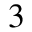Convert formula to latex. <formula><loc_0><loc_0><loc_500><loc_500>^ { 3 }</formula> 